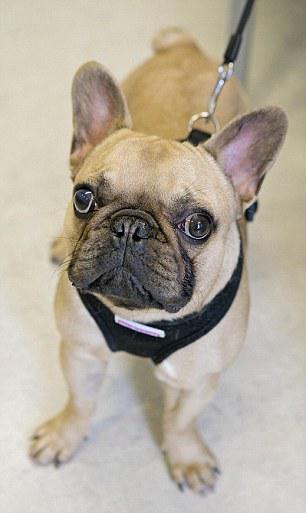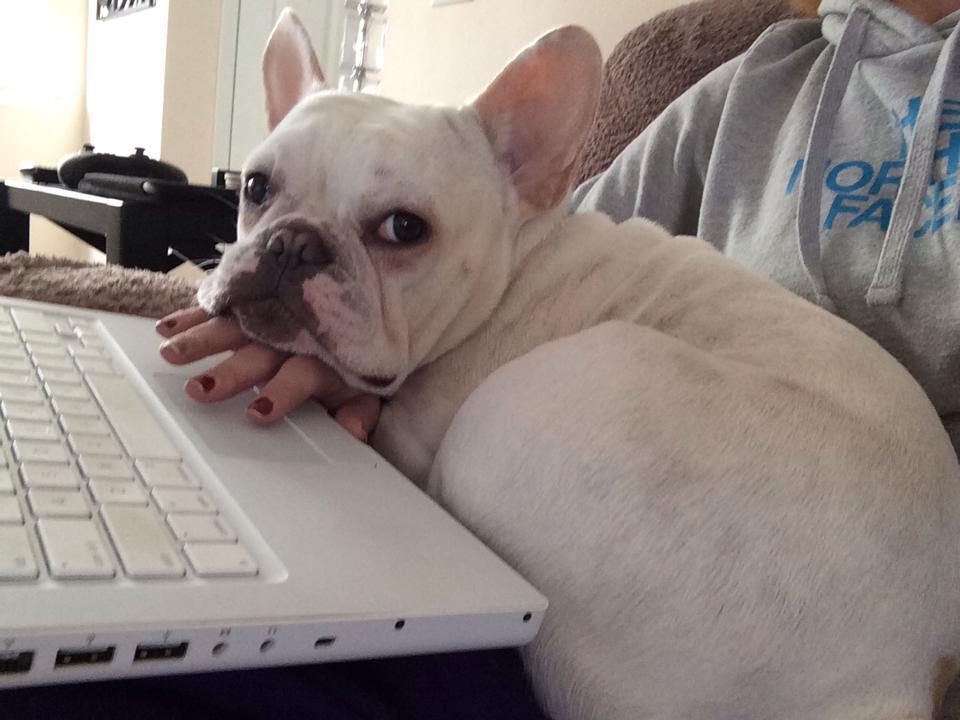The first image is the image on the left, the second image is the image on the right. Given the left and right images, does the statement "The right image contains one dark french bulldog facing forward, the left image contains a white bulldog in the foreground, and one of the dogs pictured has its tongue out." hold true? Answer yes or no. No. The first image is the image on the left, the second image is the image on the right. For the images shown, is this caption "One dog is standing." true? Answer yes or no. Yes. 